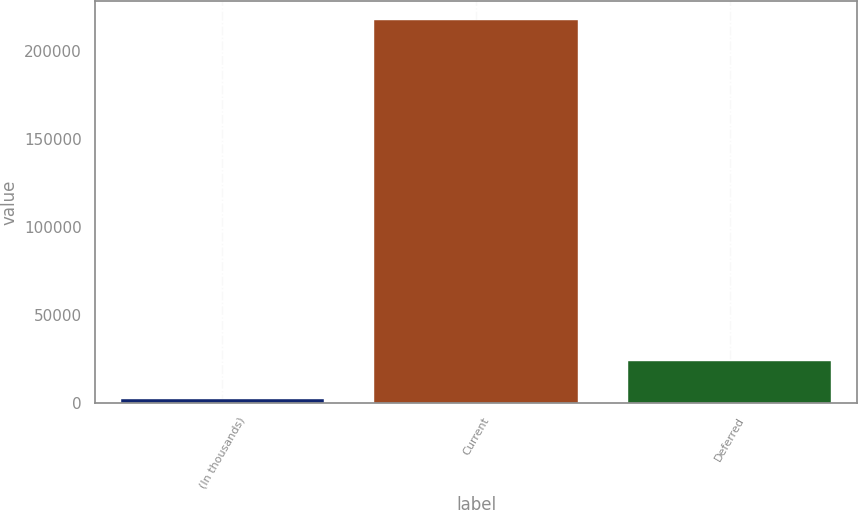Convert chart. <chart><loc_0><loc_0><loc_500><loc_500><bar_chart><fcel>(In thousands)<fcel>Current<fcel>Deferred<nl><fcel>2016<fcel>217400<fcel>23554.4<nl></chart> 